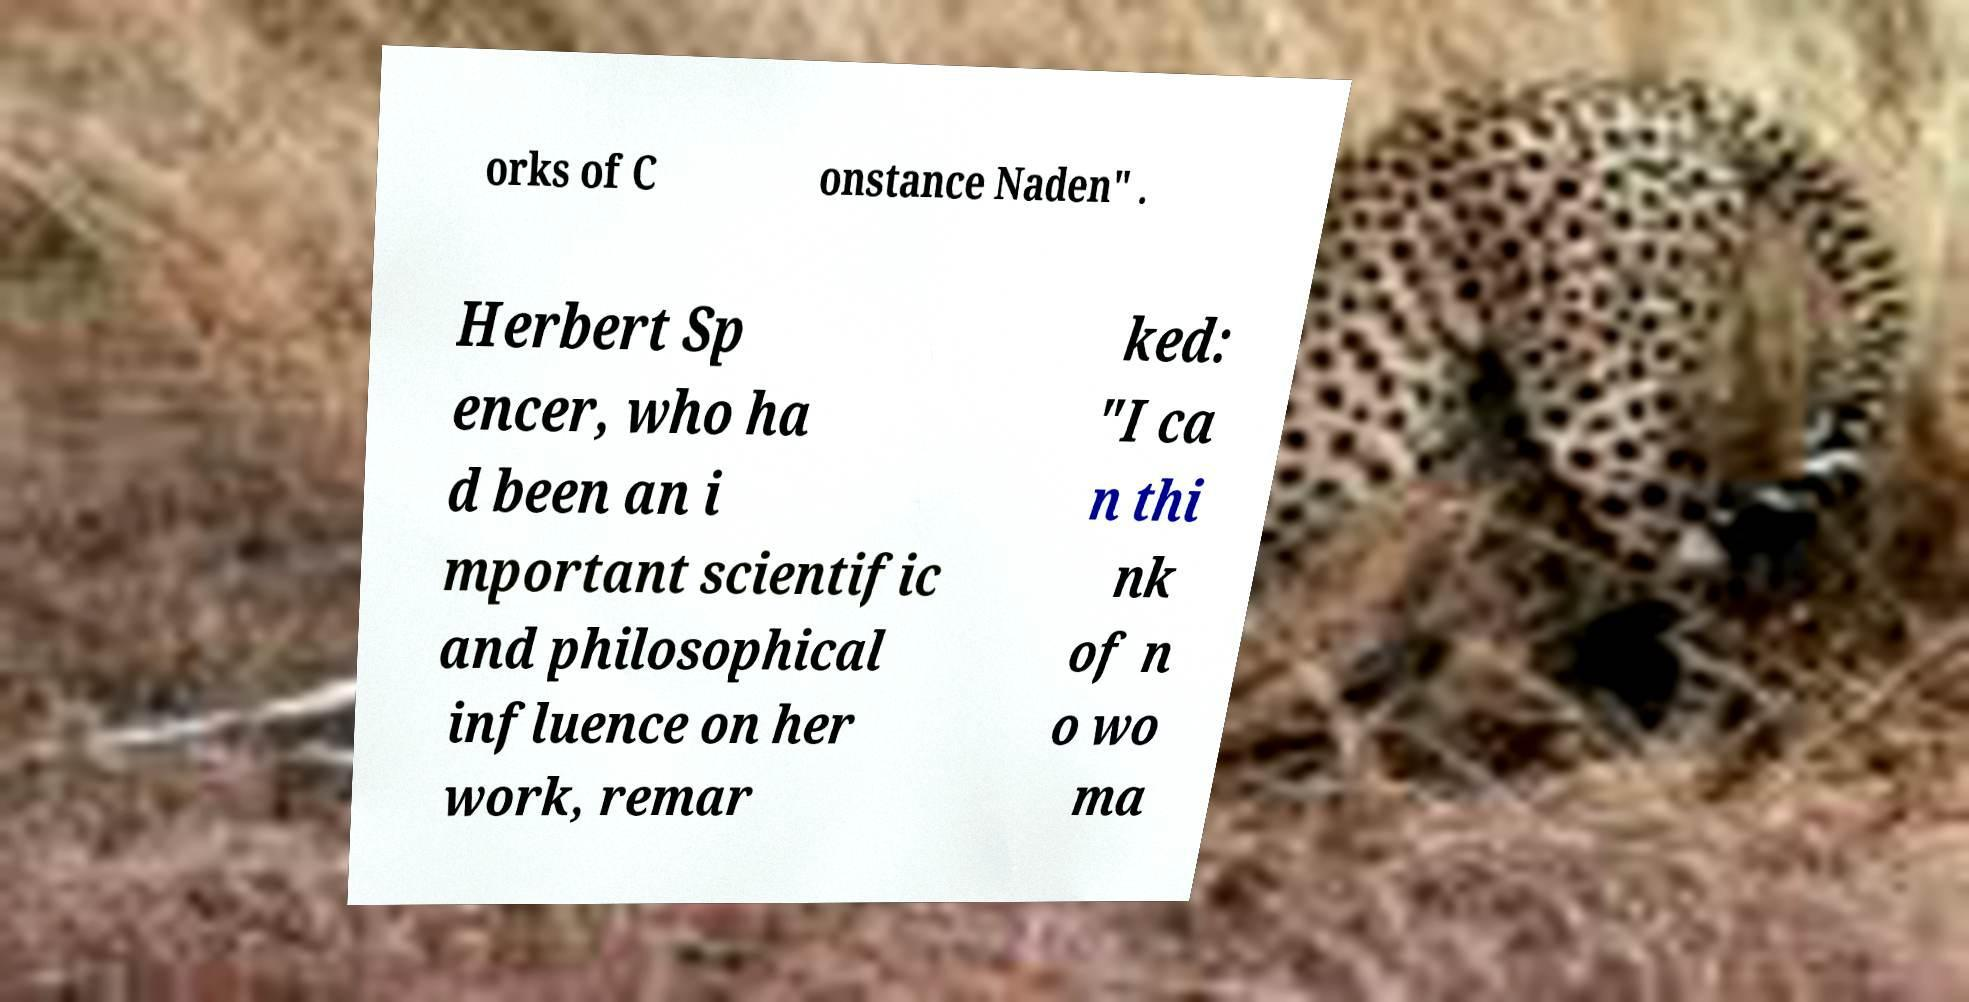Could you assist in decoding the text presented in this image and type it out clearly? orks of C onstance Naden" . Herbert Sp encer, who ha d been an i mportant scientific and philosophical influence on her work, remar ked: "I ca n thi nk of n o wo ma 